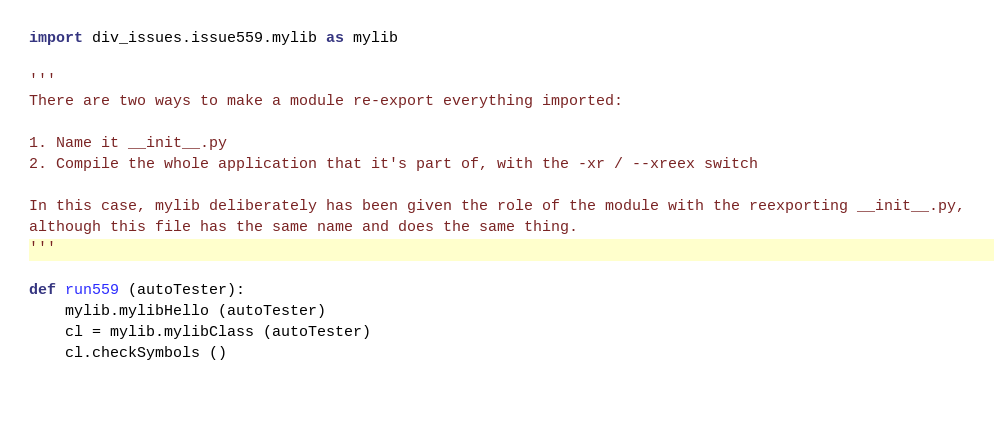<code> <loc_0><loc_0><loc_500><loc_500><_Python_>import div_issues.issue559.mylib as mylib

'''
There are two ways to make a module re-export everything imported:

1. Name it __init__.py
2. Compile the whole application that it's part of, with the -xr / --xreex switch

In this case, mylib deliberately has been given the role of the module with the reexporting __init__.py,
although this file has the same name and does the same thing.
'''

def run559 (autoTester):
    mylib.mylibHello (autoTester)
    cl = mylib.mylibClass (autoTester)
    cl.checkSymbols ()
    
    </code> 